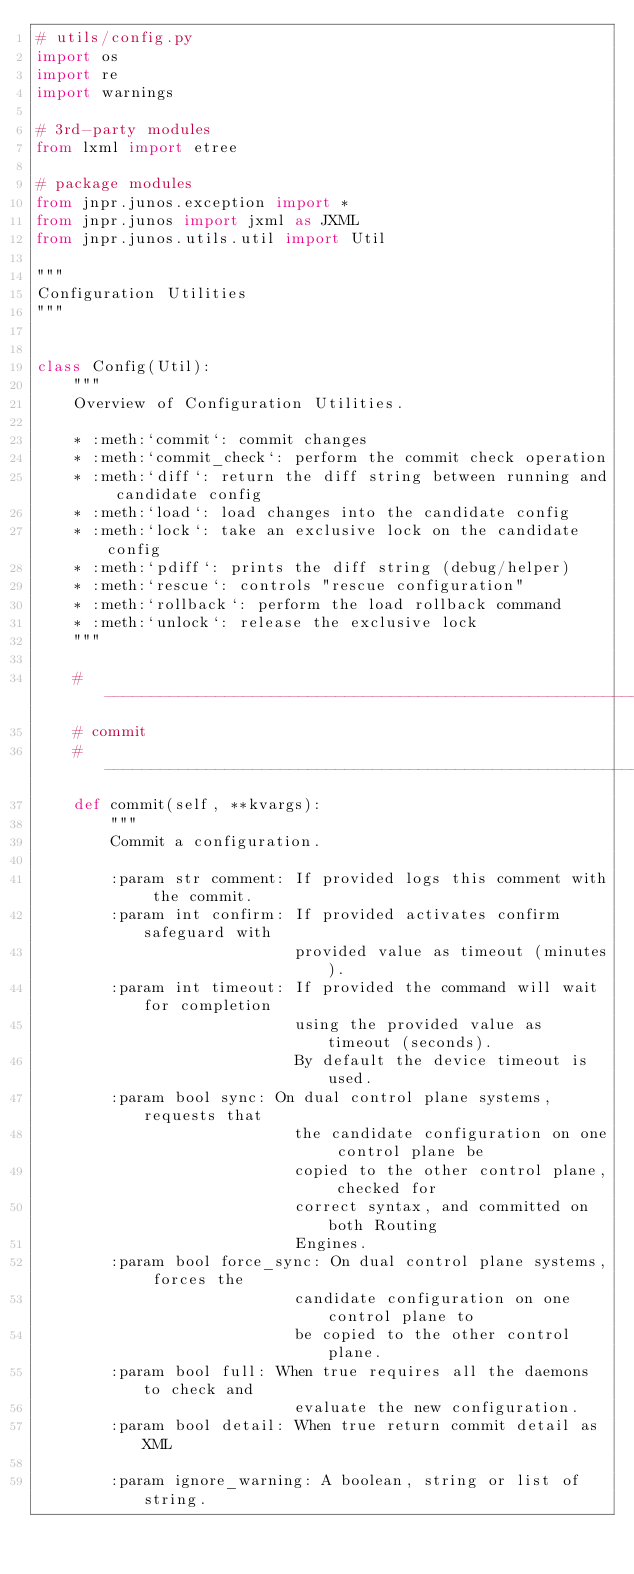<code> <loc_0><loc_0><loc_500><loc_500><_Python_># utils/config.py
import os
import re
import warnings

# 3rd-party modules
from lxml import etree

# package modules
from jnpr.junos.exception import *
from jnpr.junos import jxml as JXML
from jnpr.junos.utils.util import Util

"""
Configuration Utilities
"""


class Config(Util):
    """
    Overview of Configuration Utilities.

    * :meth:`commit`: commit changes
    * :meth:`commit_check`: perform the commit check operation
    * :meth:`diff`: return the diff string between running and candidate config
    * :meth:`load`: load changes into the candidate config
    * :meth:`lock`: take an exclusive lock on the candidate config
    * :meth:`pdiff`: prints the diff string (debug/helper)
    * :meth:`rescue`: controls "rescue configuration"
    * :meth:`rollback`: perform the load rollback command
    * :meth:`unlock`: release the exclusive lock
    """

    # ------------------------------------------------------------------------
    # commit
    # ------------------------------------------------------------------------
    def commit(self, **kvargs):
        """
        Commit a configuration.

        :param str comment: If provided logs this comment with the commit.
        :param int confirm: If provided activates confirm safeguard with
                            provided value as timeout (minutes).
        :param int timeout: If provided the command will wait for completion
                            using the provided value as timeout (seconds).
                            By default the device timeout is used.
        :param bool sync: On dual control plane systems, requests that
                            the candidate configuration on one control plane be
                            copied to the other control plane, checked for
                            correct syntax, and committed on both Routing
                            Engines.
        :param bool force_sync: On dual control plane systems, forces the
                            candidate configuration on one control plane to
                            be copied to the other control plane.
        :param bool full: When true requires all the daemons to check and
                            evaluate the new configuration.
        :param bool detail: When true return commit detail as XML

        :param ignore_warning: A boolean, string or list of string.</code> 